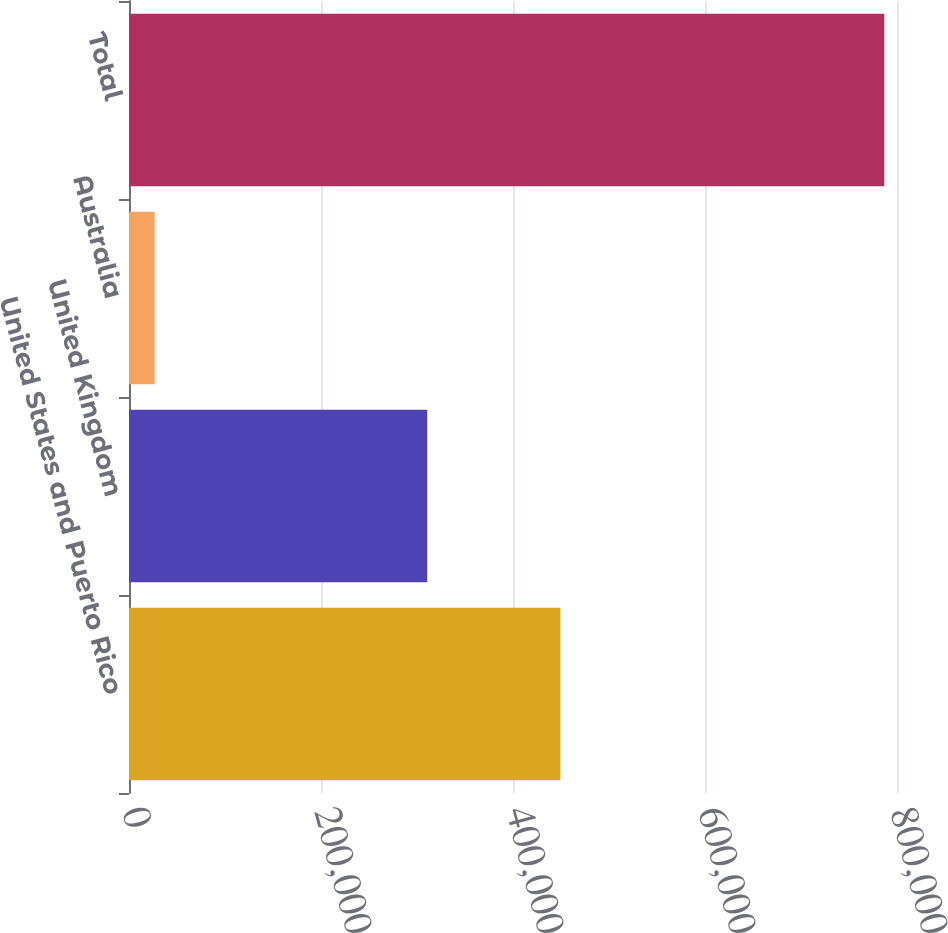Convert chart. <chart><loc_0><loc_0><loc_500><loc_500><bar_chart><fcel>United States and Puerto Rico<fcel>United Kingdom<fcel>Australia<fcel>Total<nl><fcel>449426<fcel>310634<fcel>26728<fcel>786788<nl></chart> 